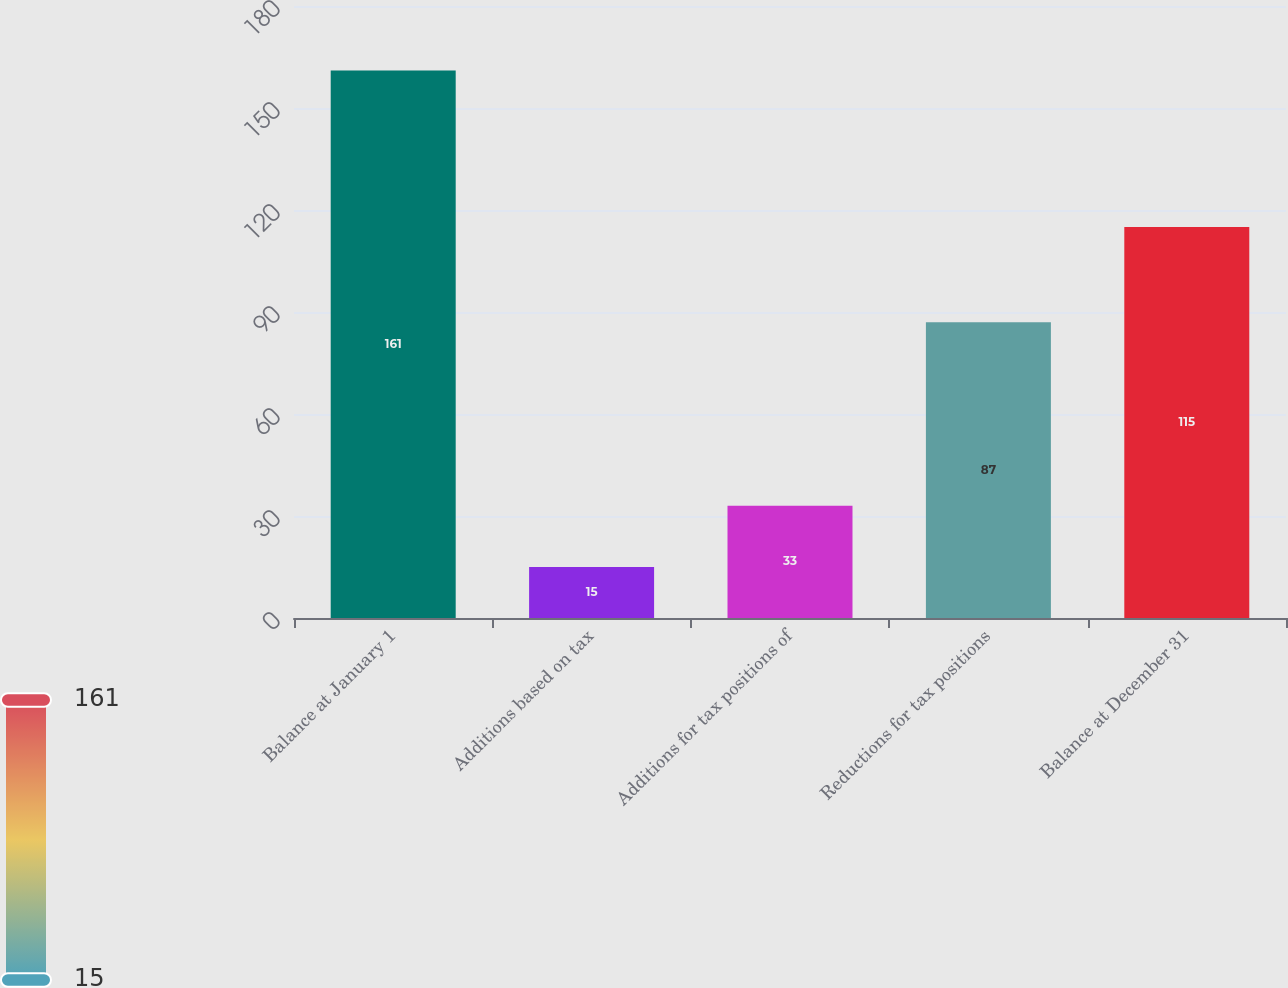Convert chart to OTSL. <chart><loc_0><loc_0><loc_500><loc_500><bar_chart><fcel>Balance at January 1<fcel>Additions based on tax<fcel>Additions for tax positions of<fcel>Reductions for tax positions<fcel>Balance at December 31<nl><fcel>161<fcel>15<fcel>33<fcel>87<fcel>115<nl></chart> 